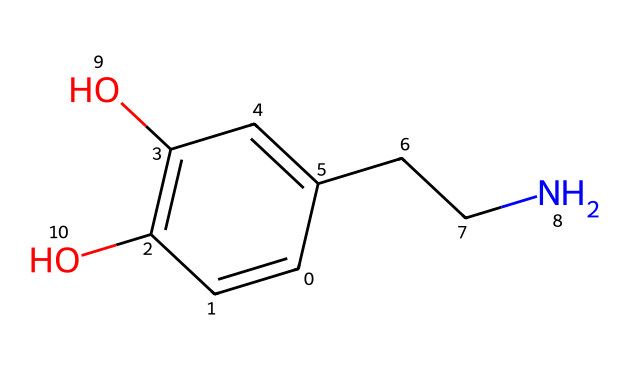What is the molecular weight of this compound? To determine the molecular weight, you need to calculate the total mass of all the atoms in the molecule based on the number of each type of atom present. The SMILES representation indicates the presence of carbon (C), hydrogen (H), oxygen (O), and nitrogen (N). Counting the atoms and using the atomic weights (C=12.01, H=1.008, O=16.00, N=14.01), you sum them up to find the molecular weight.
Answer: 153.18 g/mol How many hydroxyl (-OH) groups are present? The SMILES representation shows two oxygen atoms connected to hydrogen atoms, which indicates the presence of two -OH groups (hydroxyl groups). Each -OH represents one functional group that contains one oxygen and one hydrogen atom.
Answer: 2 What is the functional group associated with this chemical? By analyzing the structure, it's evident that there are hydroxyl (-OH) groups, which are indicative of alcohols. Additionally, the amine group (CCN) can be identified as a functional moiety. Both of these groups are crucial in determining the chemical properties and reactivity of dopamine.
Answer: alcohol, amine How many rings are present in the chemical structure? In the SMILES notation, "C1=CC(=C(C=C1..." indicates that there is a cyclic structure where 'C1' opens and closes a ring, showing that there is one aromatic ring present in the chemical. Counting the ring system reveals just one ring structure in the compound.
Answer: 1 What type of neurotransmitter is dopamine classified as based on its structure? Given the presence of the amine functional group present in the molecule, dopamine can be classified as a monoamine neurotransmitter. Monoamines are characterized by having a single amine group and play significant roles in mood and pleasure, correlating to music enjoyment as well.
Answer: monoamine 